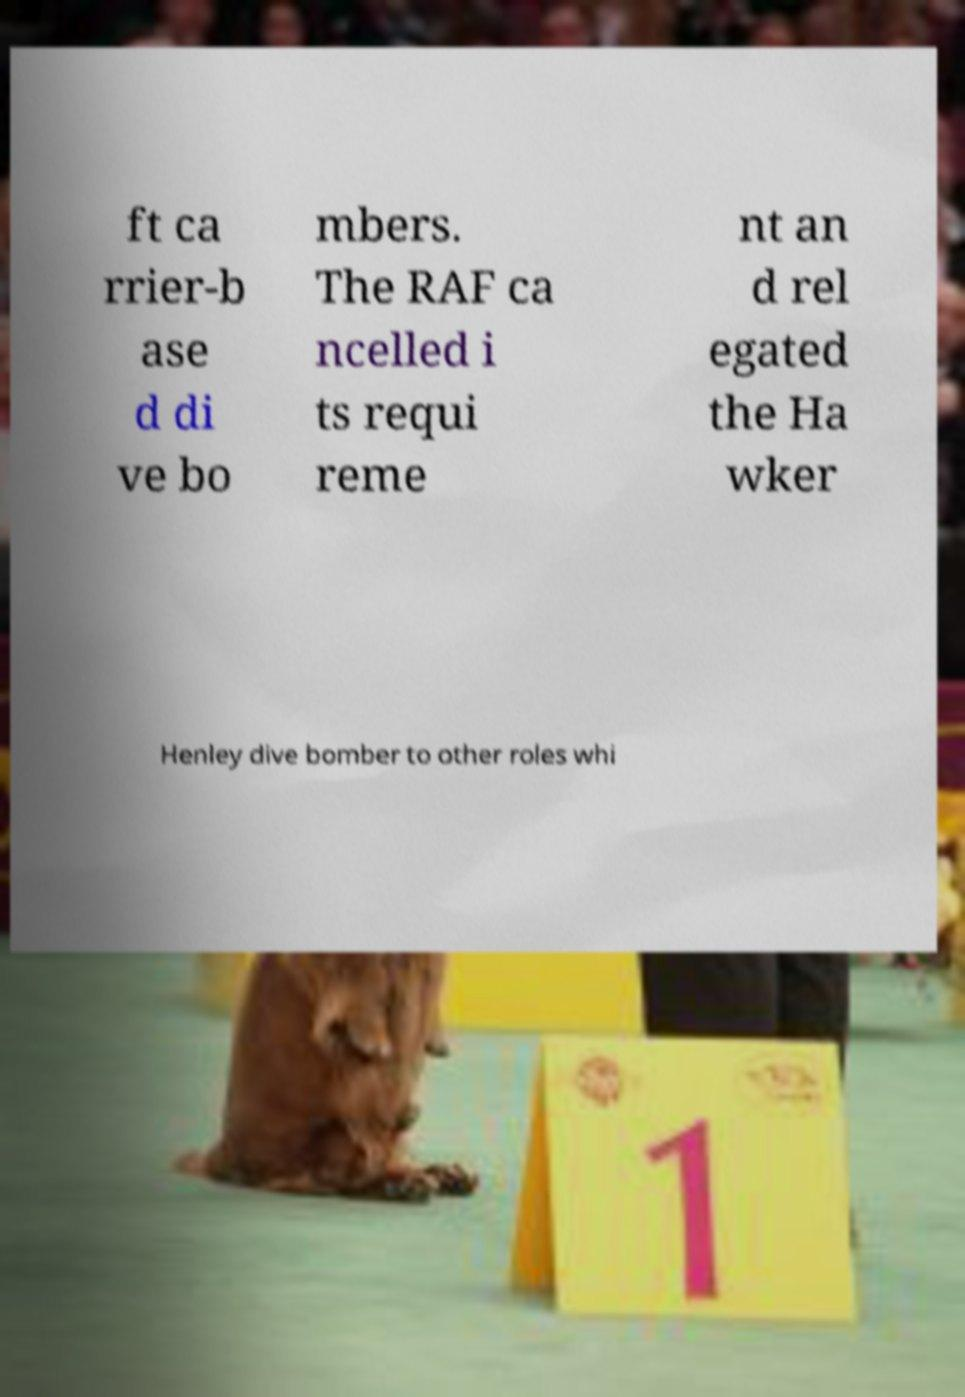There's text embedded in this image that I need extracted. Can you transcribe it verbatim? ft ca rrier-b ase d di ve bo mbers. The RAF ca ncelled i ts requi reme nt an d rel egated the Ha wker Henley dive bomber to other roles whi 